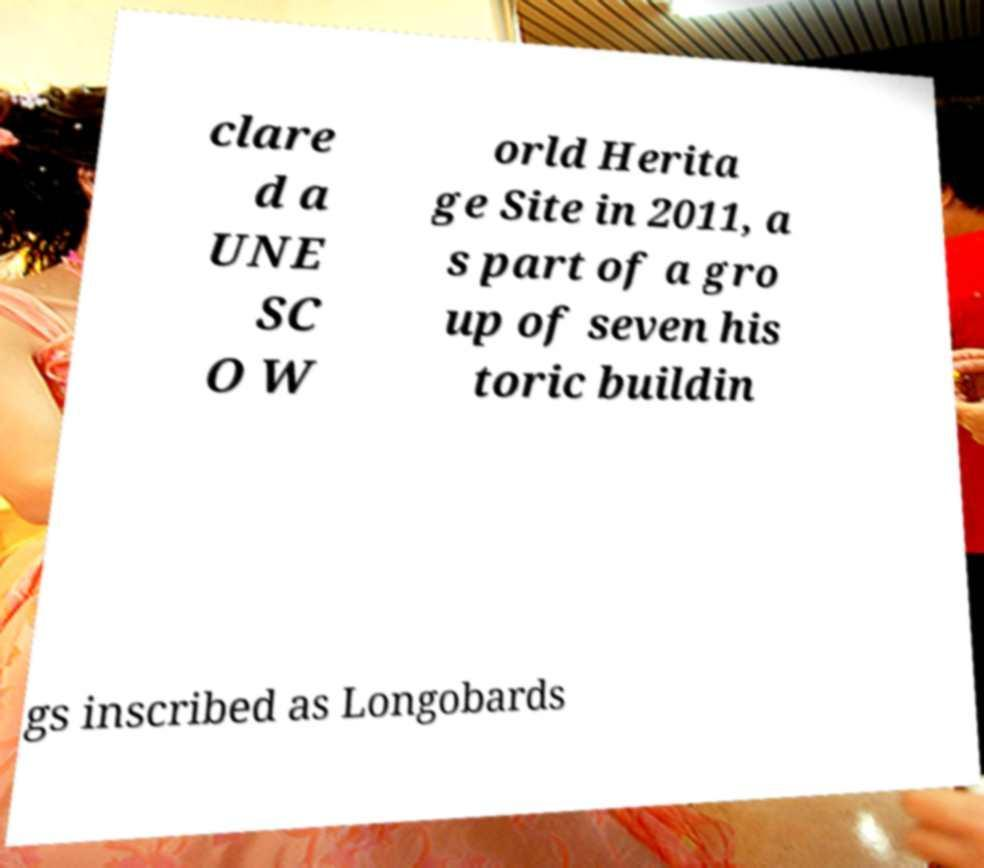What messages or text are displayed in this image? I need them in a readable, typed format. clare d a UNE SC O W orld Herita ge Site in 2011, a s part of a gro up of seven his toric buildin gs inscribed as Longobards 